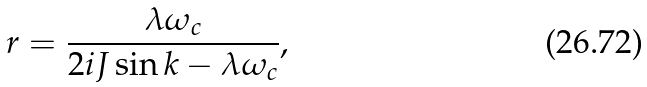<formula> <loc_0><loc_0><loc_500><loc_500>r = \frac { \lambda \omega _ { c } } { 2 i J \sin k - \lambda \omega _ { c } } ,</formula> 